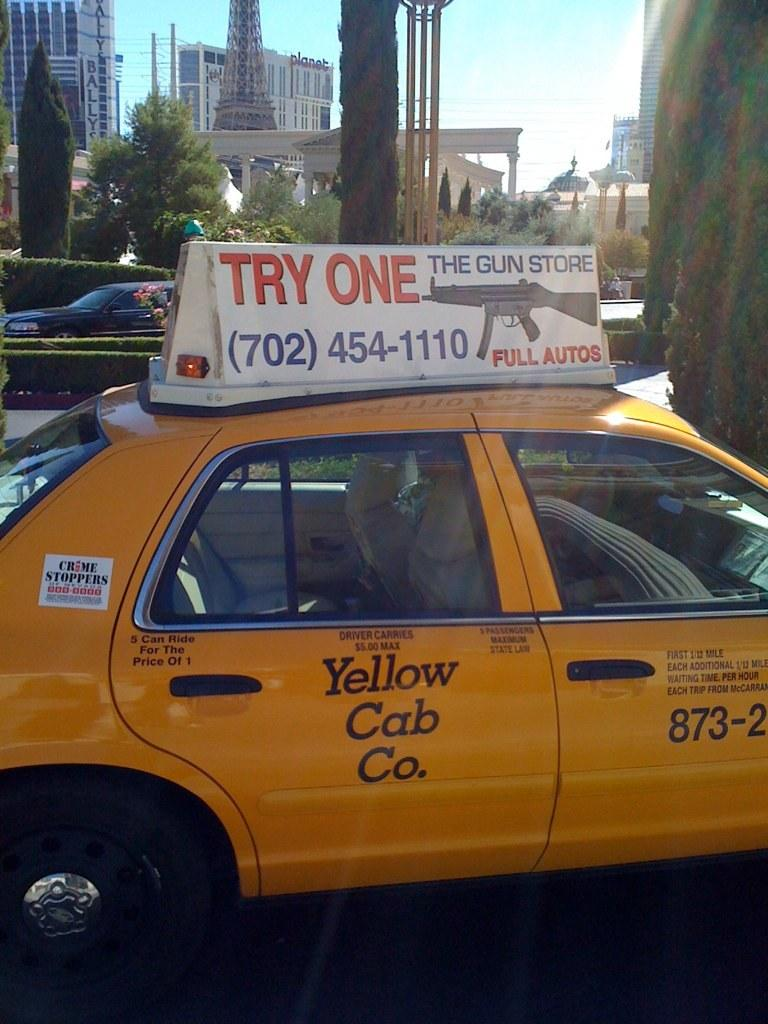<image>
Offer a succinct explanation of the picture presented. The taxi cab is promoting guns from The Gun Store. 